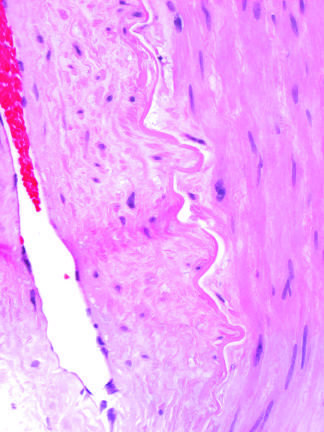s the alveolar spaces and blood vessels produced by radiation therapy of the neck region?
Answer the question using a single word or phrase. No 